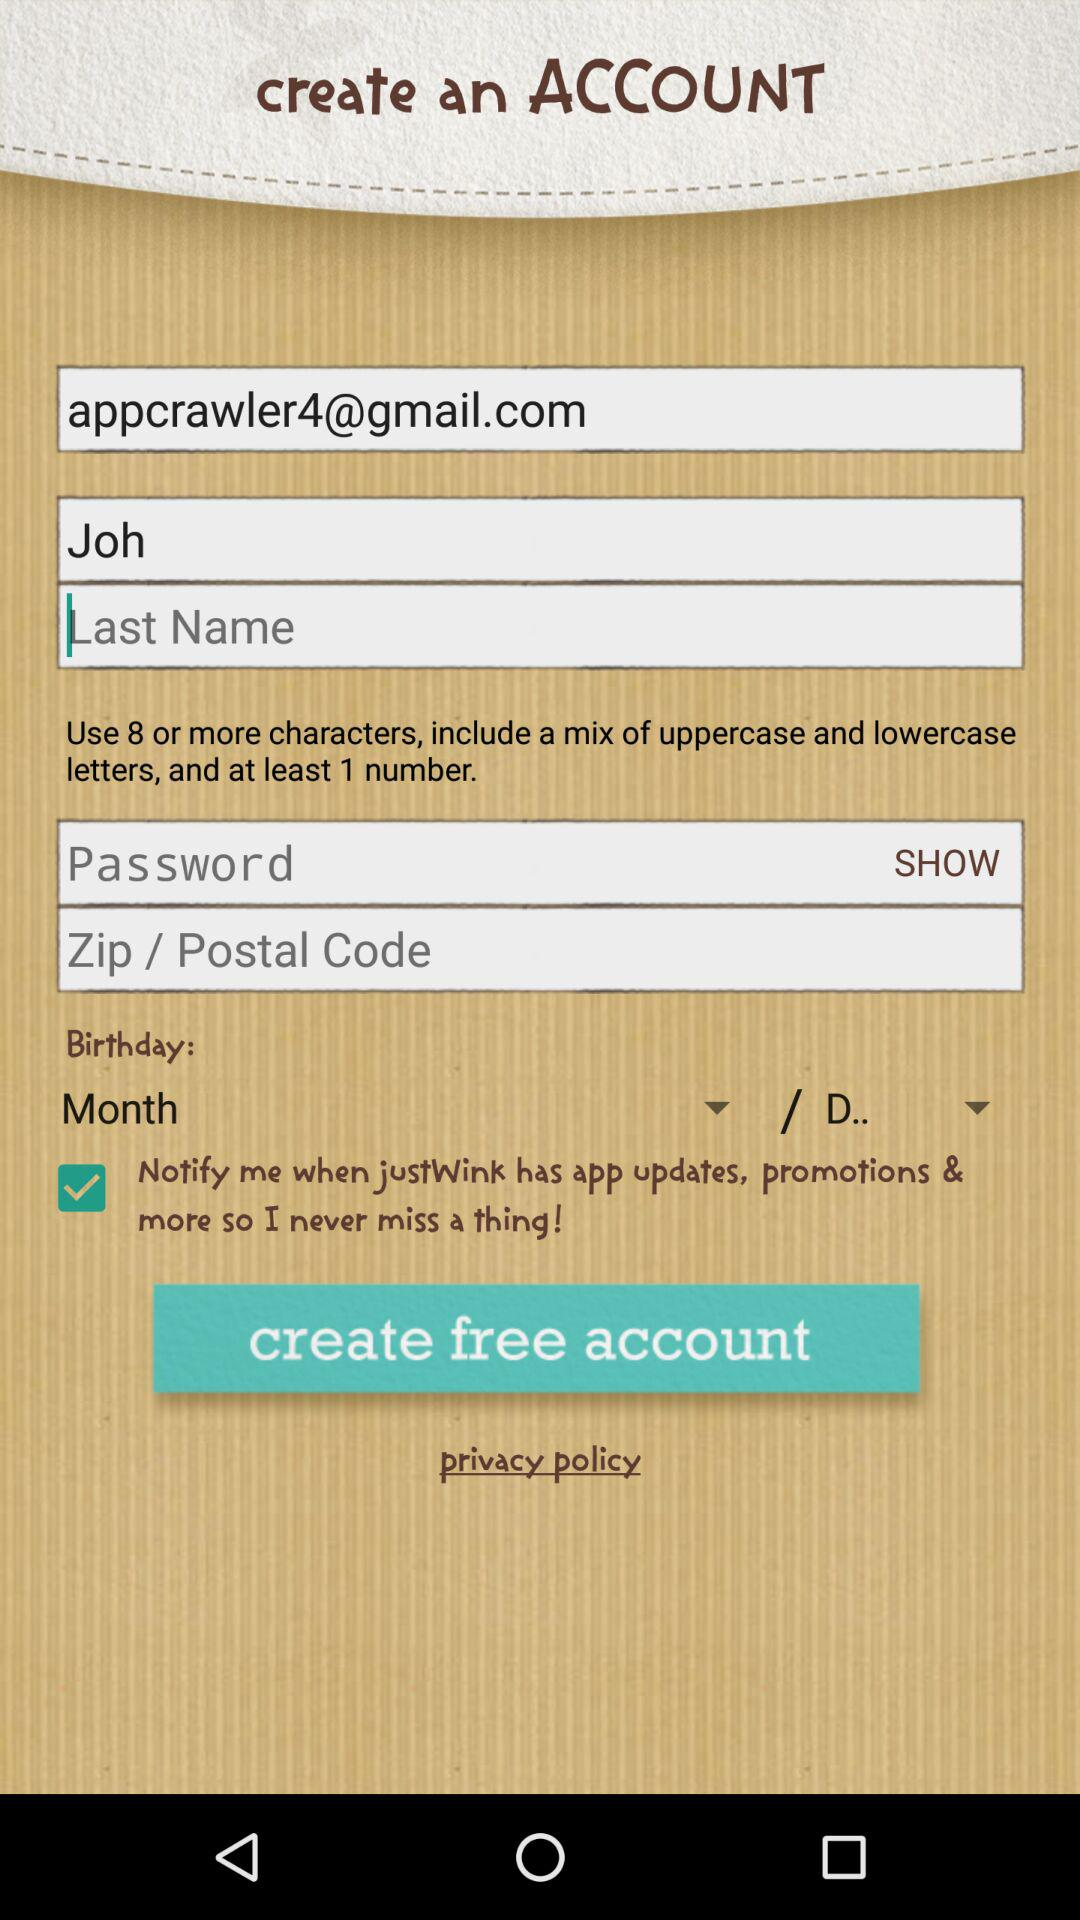What is the status of "Notify Me"? The status is "on". 